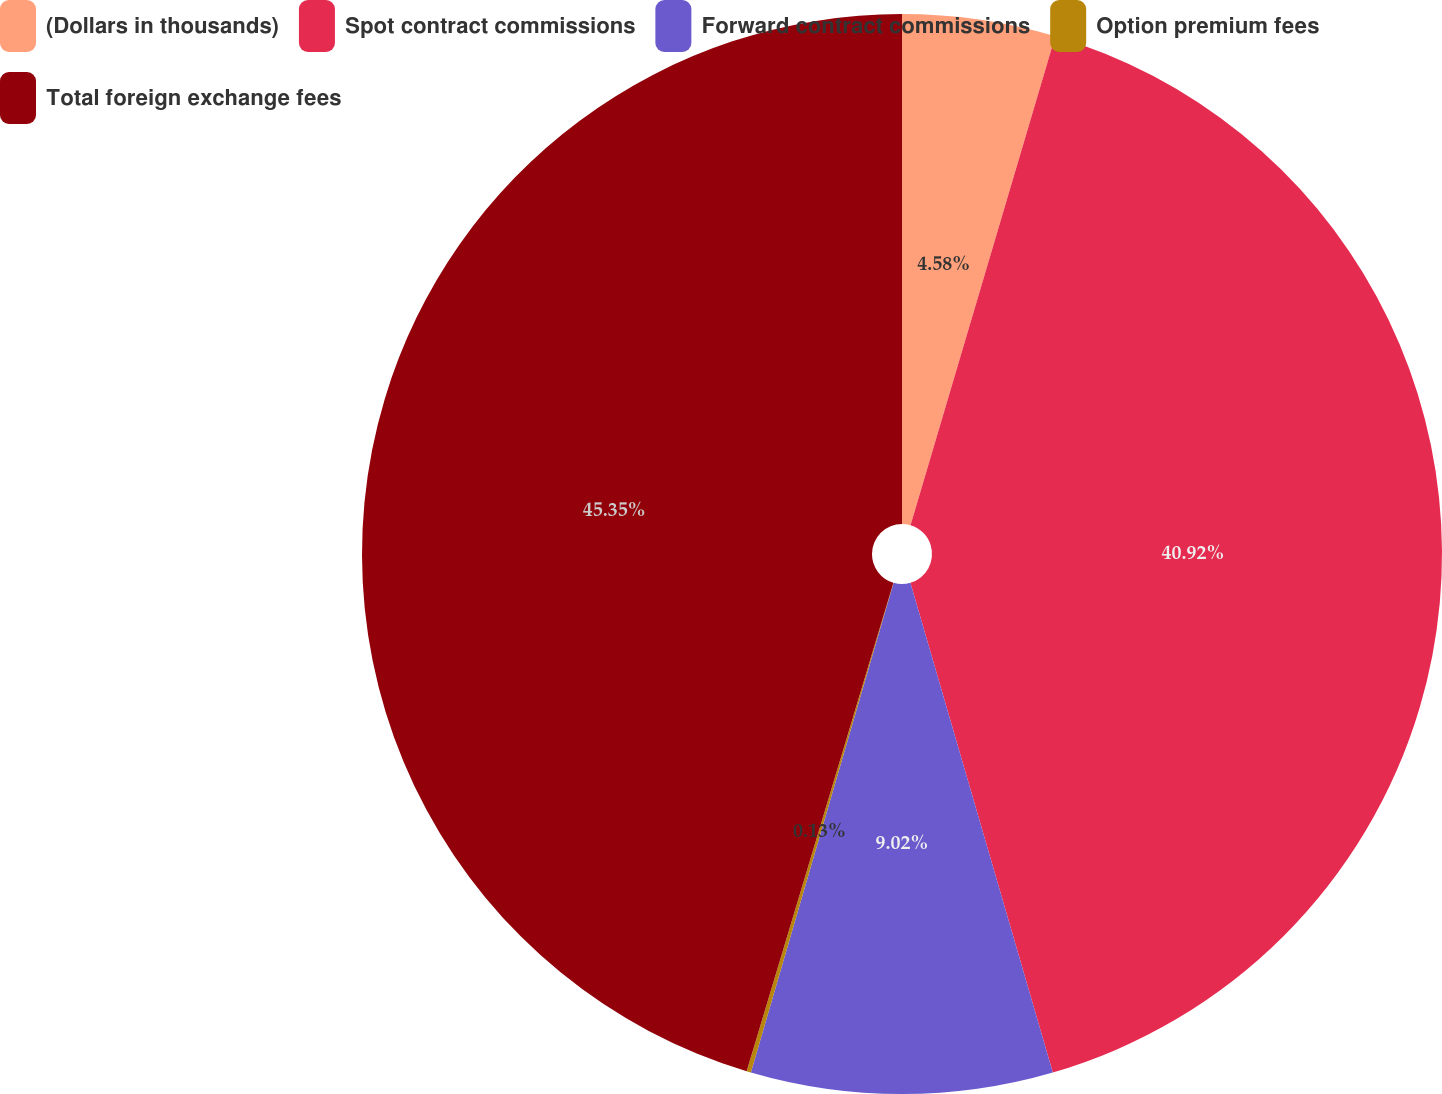Convert chart. <chart><loc_0><loc_0><loc_500><loc_500><pie_chart><fcel>(Dollars in thousands)<fcel>Spot contract commissions<fcel>Forward contract commissions<fcel>Option premium fees<fcel>Total foreign exchange fees<nl><fcel>4.58%<fcel>40.92%<fcel>9.02%<fcel>0.13%<fcel>45.36%<nl></chart> 